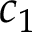<formula> <loc_0><loc_0><loc_500><loc_500>c _ { 1 }</formula> 